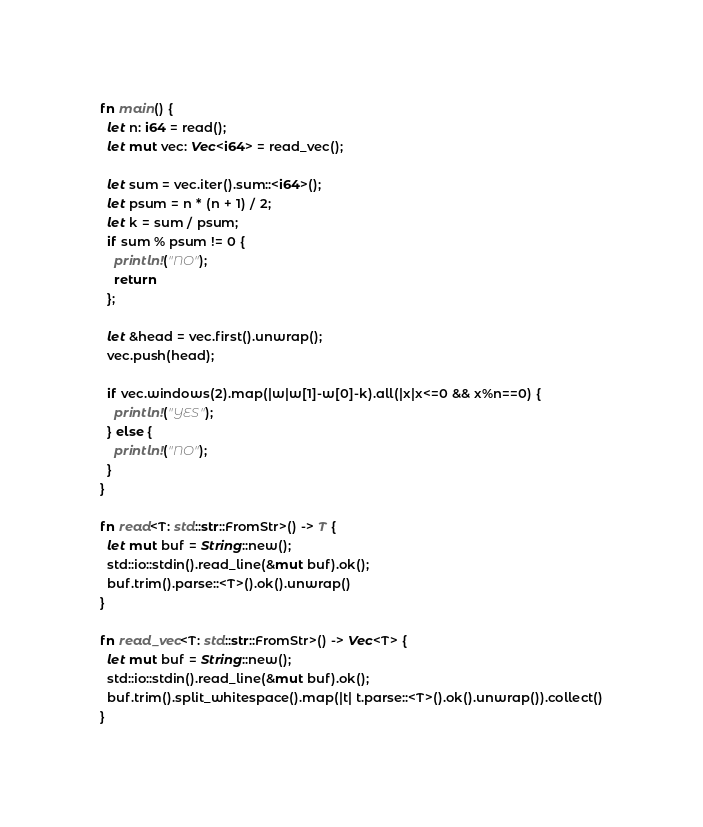Convert code to text. <code><loc_0><loc_0><loc_500><loc_500><_Rust_>fn main() {
  let n: i64 = read();
  let mut vec: Vec<i64> = read_vec();
  
  let sum = vec.iter().sum::<i64>();
  let psum = n * (n + 1) / 2;
  let k = sum / psum;
  if sum % psum != 0 {
    println!("NO");
    return
  };
  
  let &head = vec.first().unwrap();
  vec.push(head);
  
  if vec.windows(2).map(|w|w[1]-w[0]-k).all(|x|x<=0 && x%n==0) {
    println!("YES");
  } else {
    println!("NO");
  }
}

fn read<T: std::str::FromStr>() -> T {
  let mut buf = String::new();
  std::io::stdin().read_line(&mut buf).ok();
  buf.trim().parse::<T>().ok().unwrap()
}

fn read_vec<T: std::str::FromStr>() -> Vec<T> {
  let mut buf = String::new();
  std::io::stdin().read_line(&mut buf).ok();
  buf.trim().split_whitespace().map(|t| t.parse::<T>().ok().unwrap()).collect()
}</code> 